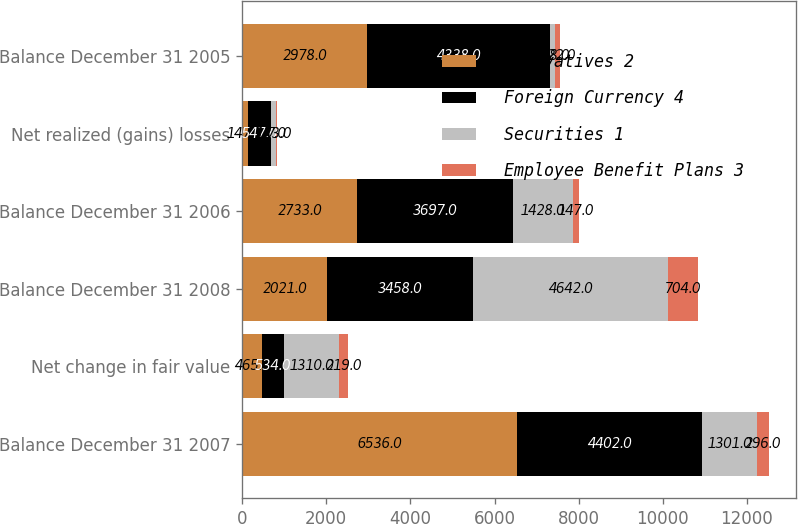Convert chart. <chart><loc_0><loc_0><loc_500><loc_500><stacked_bar_chart><ecel><fcel>Balance December 31 2007<fcel>Net change in fair value<fcel>Balance December 31 2008<fcel>Balance December 31 2006<fcel>Net realized (gains) losses<fcel>Balance December 31 2005<nl><fcel>Derivatives 2<fcel>6536<fcel>465<fcel>2021<fcel>2733<fcel>147<fcel>2978<nl><fcel>Foreign Currency 4<fcel>4402<fcel>534<fcel>3458<fcel>3697<fcel>547<fcel>4338<nl><fcel>Securities 1<fcel>1301<fcel>1310<fcel>4642<fcel>1428<fcel>123<fcel>118<nl><fcel>Employee Benefit Plans 3<fcel>296<fcel>219<fcel>704<fcel>147<fcel>7<fcel>122<nl></chart> 